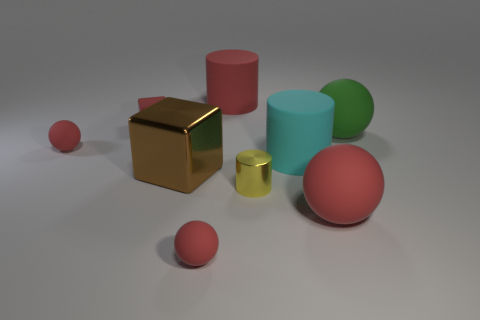Subtract all brown blocks. How many red spheres are left? 3 Subtract all blue cylinders. Subtract all purple spheres. How many cylinders are left? 3 Add 1 purple metal cylinders. How many objects exist? 10 Subtract all cylinders. How many objects are left? 6 Add 8 brown shiny cubes. How many brown shiny cubes are left? 9 Add 8 purple metal blocks. How many purple metal blocks exist? 8 Subtract 0 cyan balls. How many objects are left? 9 Subtract all green rubber blocks. Subtract all large rubber things. How many objects are left? 5 